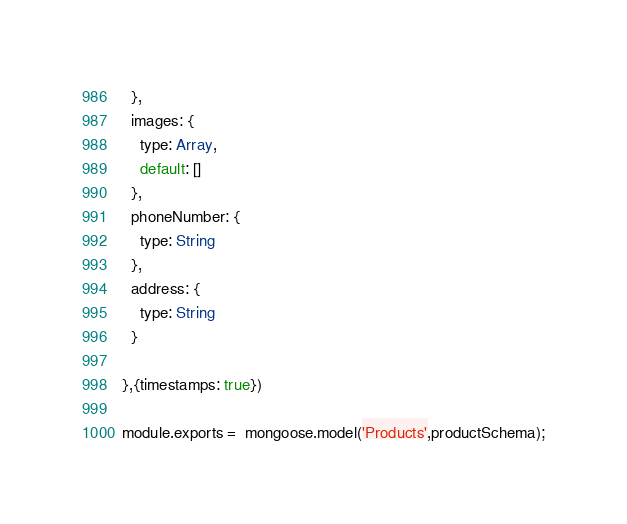Convert code to text. <code><loc_0><loc_0><loc_500><loc_500><_JavaScript_>  },
  images: {
    type: Array,
    default: []
  },
  phoneNumber: {
    type: String
  },
  address: {
    type: String
  }

},{timestamps: true})

module.exports =  mongoose.model('Products',productSchema);

</code> 